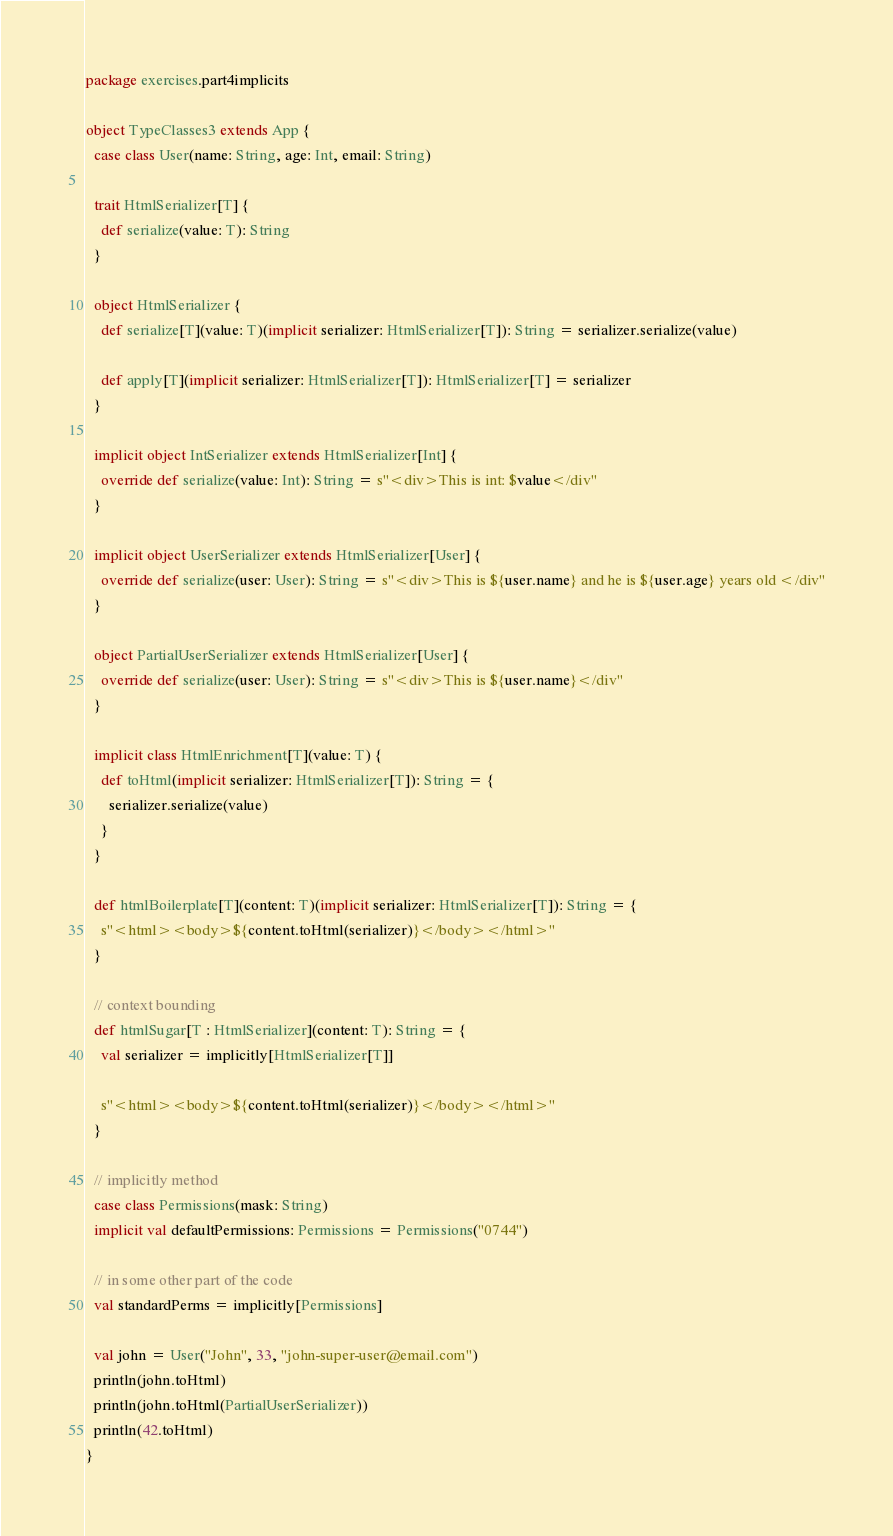<code> <loc_0><loc_0><loc_500><loc_500><_Scala_>package exercises.part4implicits

object TypeClasses3 extends App {
  case class User(name: String, age: Int, email: String)

  trait HtmlSerializer[T] {
    def serialize(value: T): String
  }

  object HtmlSerializer {
    def serialize[T](value: T)(implicit serializer: HtmlSerializer[T]): String = serializer.serialize(value)

    def apply[T](implicit serializer: HtmlSerializer[T]): HtmlSerializer[T] = serializer
  }

  implicit object IntSerializer extends HtmlSerializer[Int] {
    override def serialize(value: Int): String = s"<div>This is int: $value</div"
  }

  implicit object UserSerializer extends HtmlSerializer[User] {
    override def serialize(user: User): String = s"<div>This is ${user.name} and he is ${user.age} years old </div"
  }

  object PartialUserSerializer extends HtmlSerializer[User] {
    override def serialize(user: User): String = s"<div>This is ${user.name}</div"
  }

  implicit class HtmlEnrichment[T](value: T) {
    def toHtml(implicit serializer: HtmlSerializer[T]): String = {
      serializer.serialize(value)
    }
  }

  def htmlBoilerplate[T](content: T)(implicit serializer: HtmlSerializer[T]): String = {
    s"<html><body>${content.toHtml(serializer)}</body></html>"
  }

  // context bounding
  def htmlSugar[T : HtmlSerializer](content: T): String = {
    val serializer = implicitly[HtmlSerializer[T]]

    s"<html><body>${content.toHtml(serializer)}</body></html>"
  }

  // implicitly method
  case class Permissions(mask: String)
  implicit val defaultPermissions: Permissions = Permissions("0744")

  // in some other part of the code
  val standardPerms = implicitly[Permissions]

  val john = User("John", 33, "john-super-user@email.com")
  println(john.toHtml)
  println(john.toHtml(PartialUserSerializer))
  println(42.toHtml)
}
</code> 